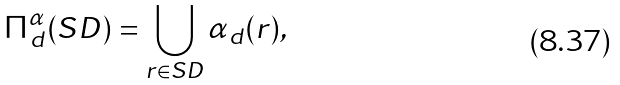<formula> <loc_0><loc_0><loc_500><loc_500>\Pi ^ { \alpha } _ { d } ( S D ) = \bigcup _ { r \in S D } \alpha _ { d } ( r ) ,</formula> 